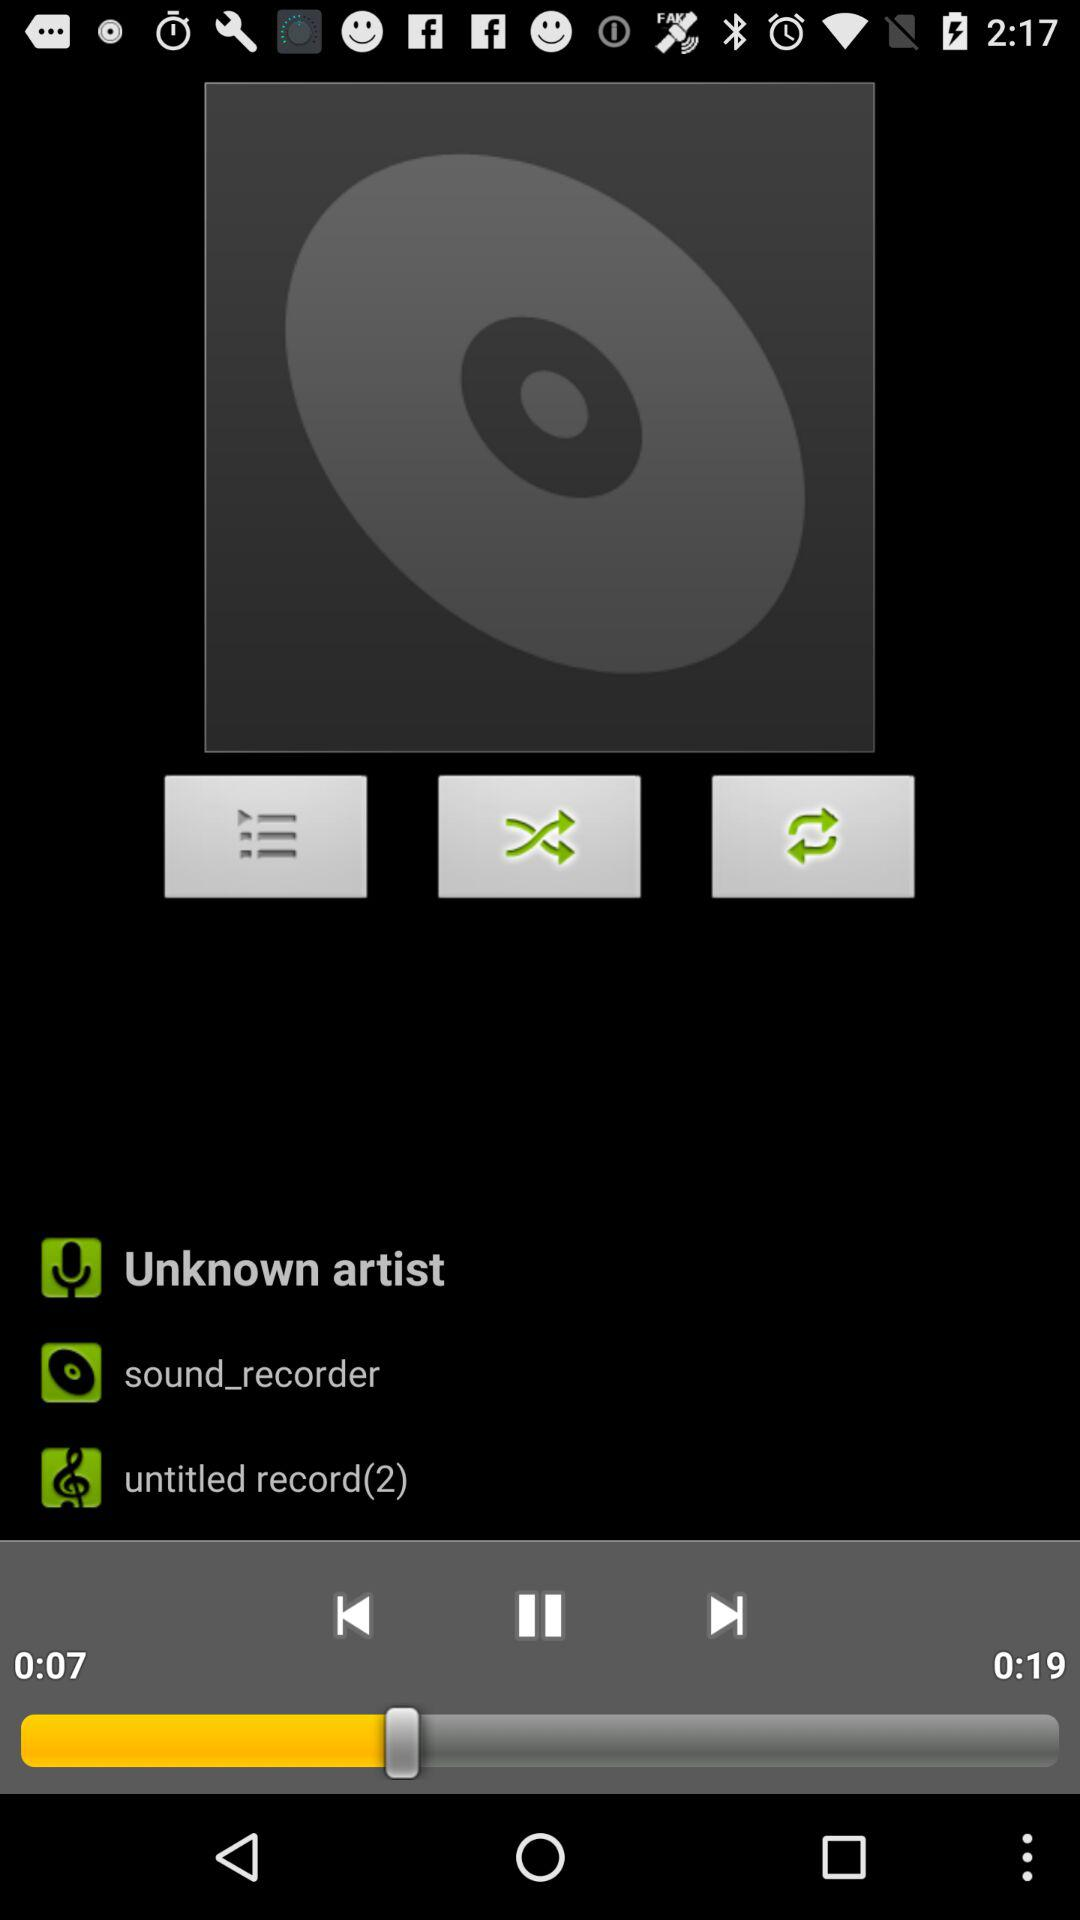How long is the current track?
Answer the question using a single word or phrase. 0:19 